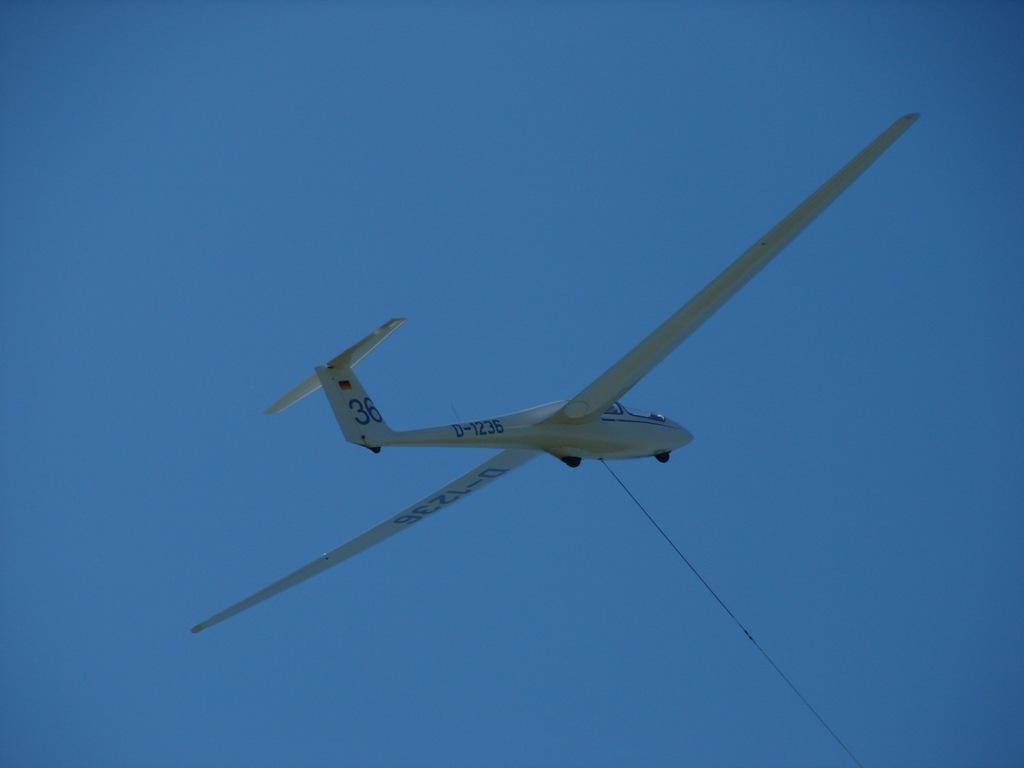What is the main subject of the picture? The main subject of the picture is a plane. Is there anything connected to the plane in the image? Yes, a rope is attached to the plane. What can be seen in the background of the picture? The sky is visible in the picture. What type of silk fabric is draped over the plane in the image? There is no silk fabric present in the image; the plane has a rope attached to it. What time is indicated by the clock in the image? There is no clock present in the image. 